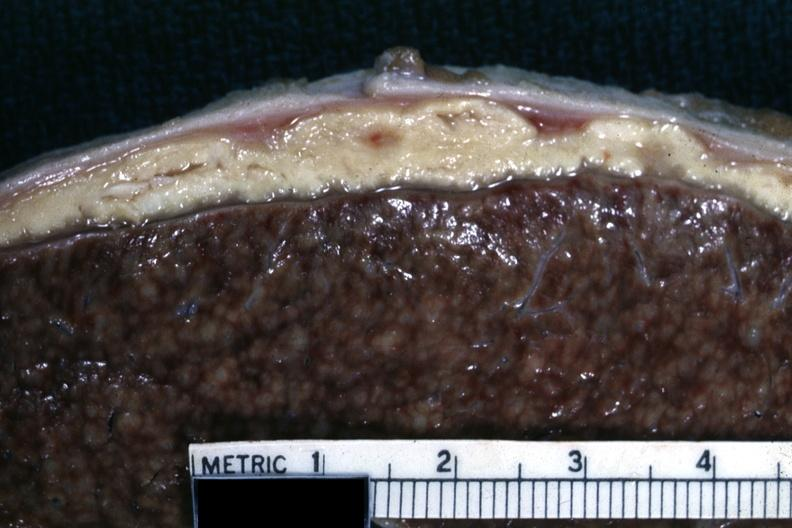where is this area in the body?
Answer the question using a single word or phrase. Abdomen 